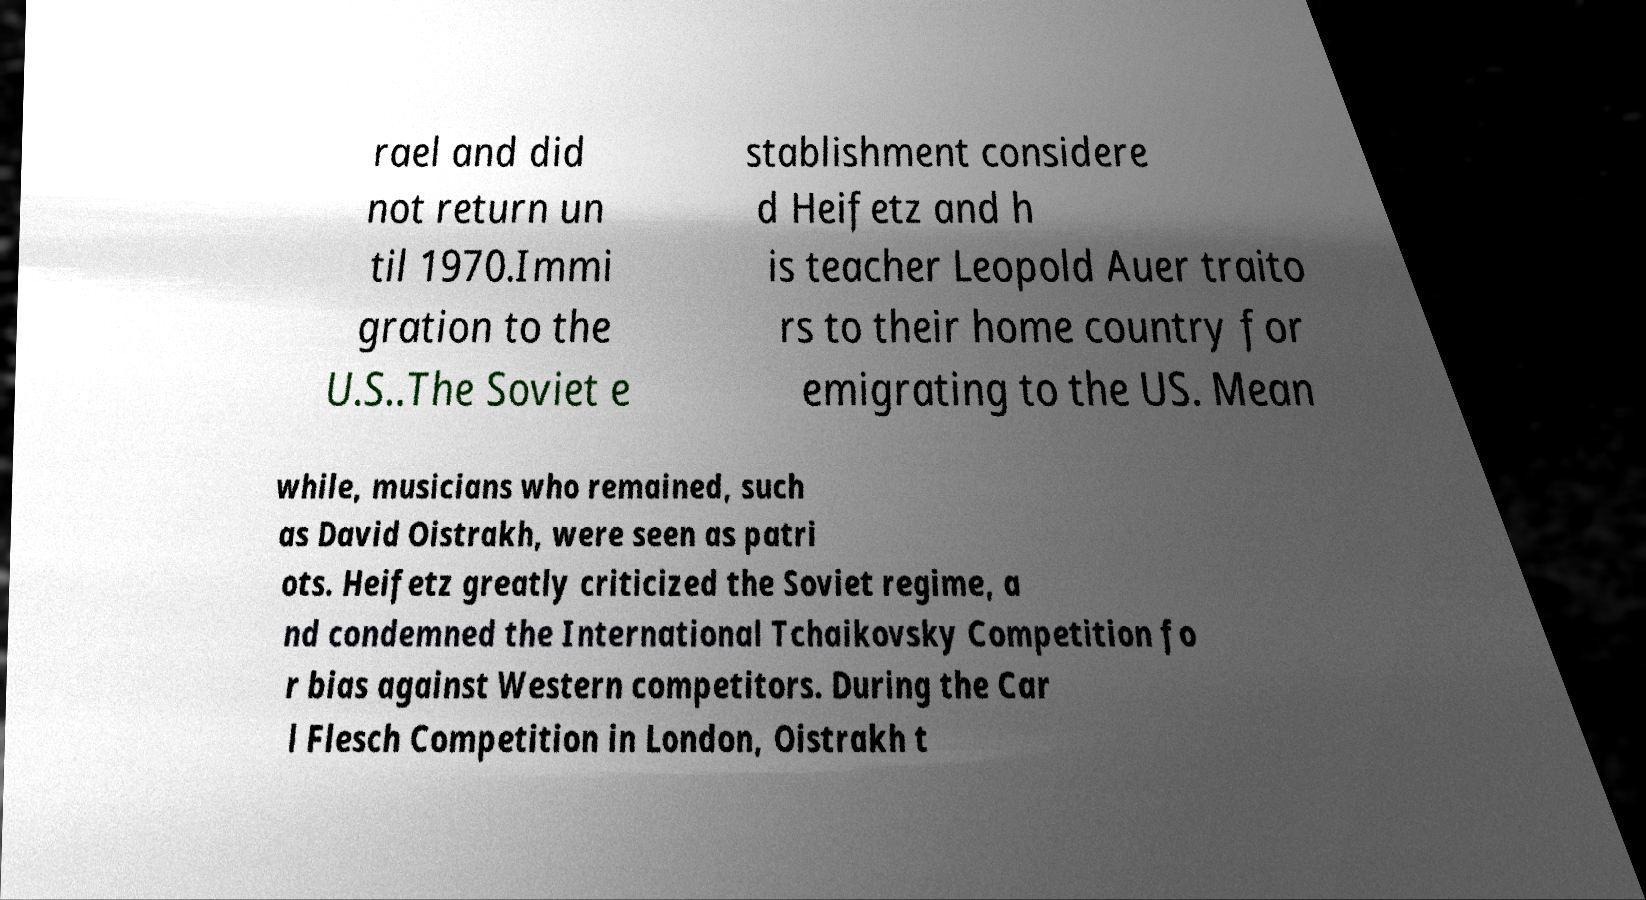Please read and relay the text visible in this image. What does it say? rael and did not return un til 1970.Immi gration to the U.S..The Soviet e stablishment considere d Heifetz and h is teacher Leopold Auer traito rs to their home country for emigrating to the US. Mean while, musicians who remained, such as David Oistrakh, were seen as patri ots. Heifetz greatly criticized the Soviet regime, a nd condemned the International Tchaikovsky Competition fo r bias against Western competitors. During the Car l Flesch Competition in London, Oistrakh t 